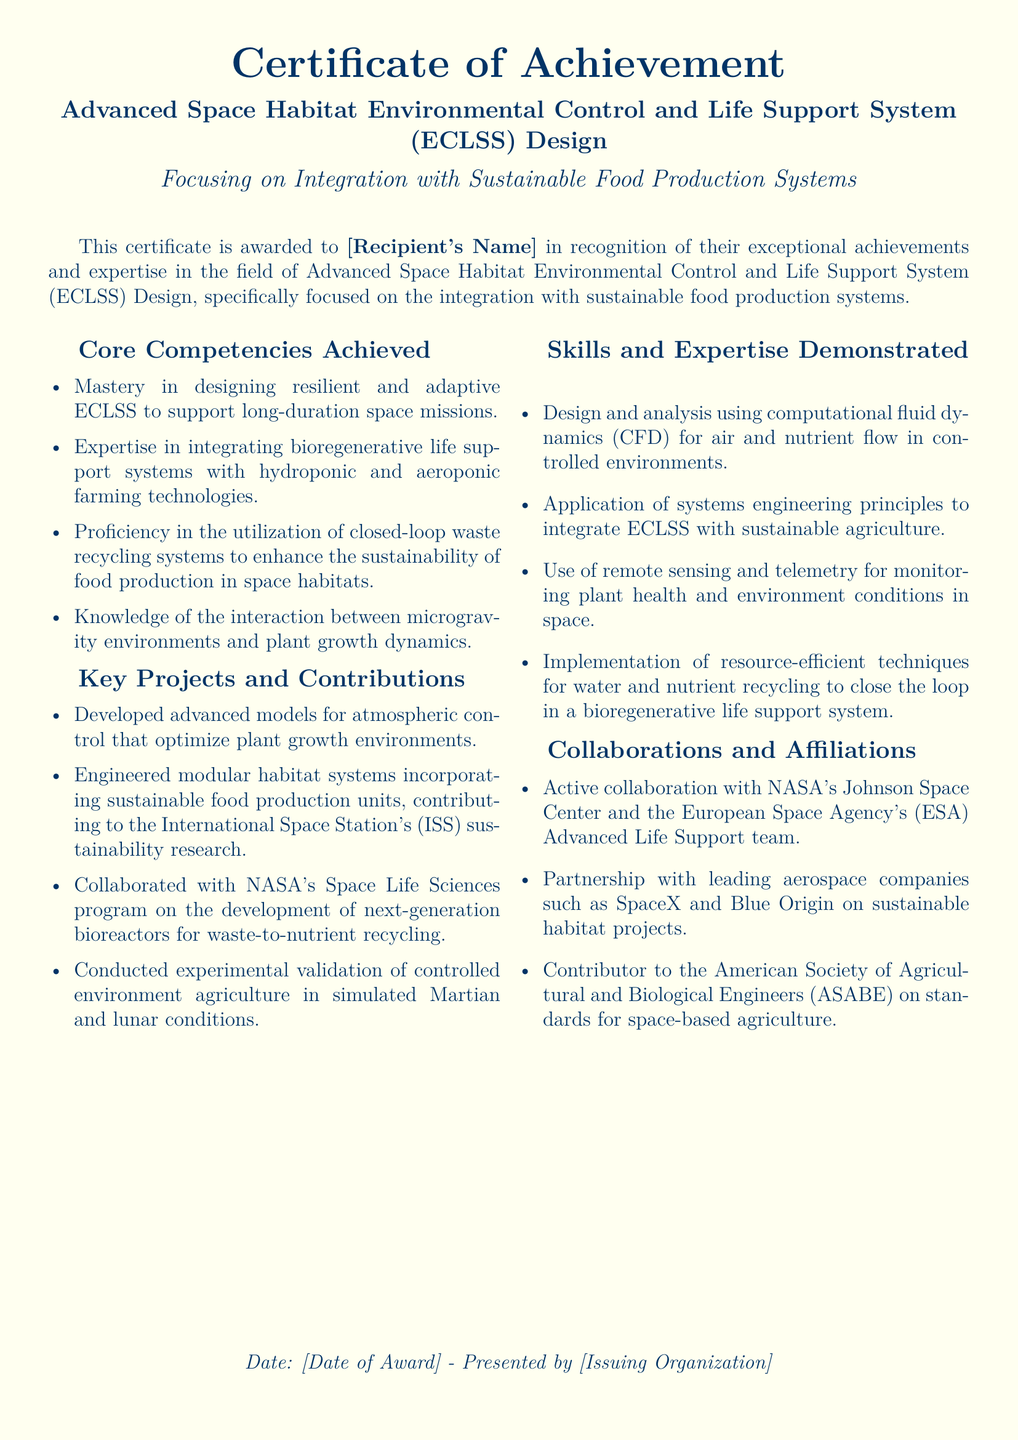What is the title of the certificate? The title of the certificate is stated in the document, which highlights the specific achievement and focus area.
Answer: Advanced Space Habitat Environmental Control and Life Support System (ECLSS) Design Who is the recipient of the certificate? The recipient's name is mentioned in the document, indicated by a placeholder meant to be filled in.
Answer: [Recipient's Name] What is the date of the award? The date of the award is specifically mentioned in the document, indicated by a placeholder for custom entry.
Answer: [Date of Award] Which organization presented the certificate? The issuing organization is included in the document, shown in a designated area for custom entry.
Answer: [Issuing Organization] What core competency involves plant growth dynamics? The core competency focuses on the interaction between a specific environment and growth factors, detailed in a bullet list.
Answer: Knowledge of the interaction between microgravity environments and plant growth dynamics How many key projects are listed in the document? The total number of key projects is determined by counting the bullet points in the respective section.
Answer: Four Which organization is mentioned as an active collaborator? A specific organization is identified in the collaborations section as collaborating with the recipient.
Answer: NASA's Johnson Space Center What type of engineering principles were applied for ECLSS integration? The engineering principle applied is indicated in the skills section that focuses on system integration.
Answer: Systems engineering principles What is the main focus of the certificate? The main focus is detailed in the subtitle of the document, which clarifies the specialization area of the achievement.
Answer: Integration with Sustainable Food Production Systems 